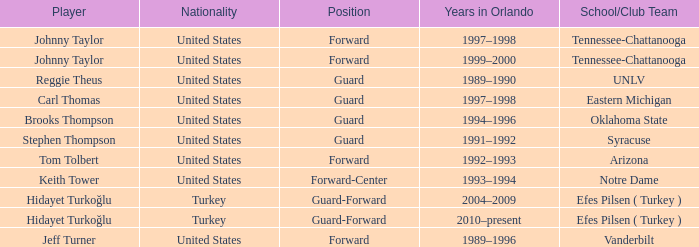What school or club team does stephen thompson belong to? Syracuse. 